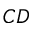<formula> <loc_0><loc_0><loc_500><loc_500>C D</formula> 